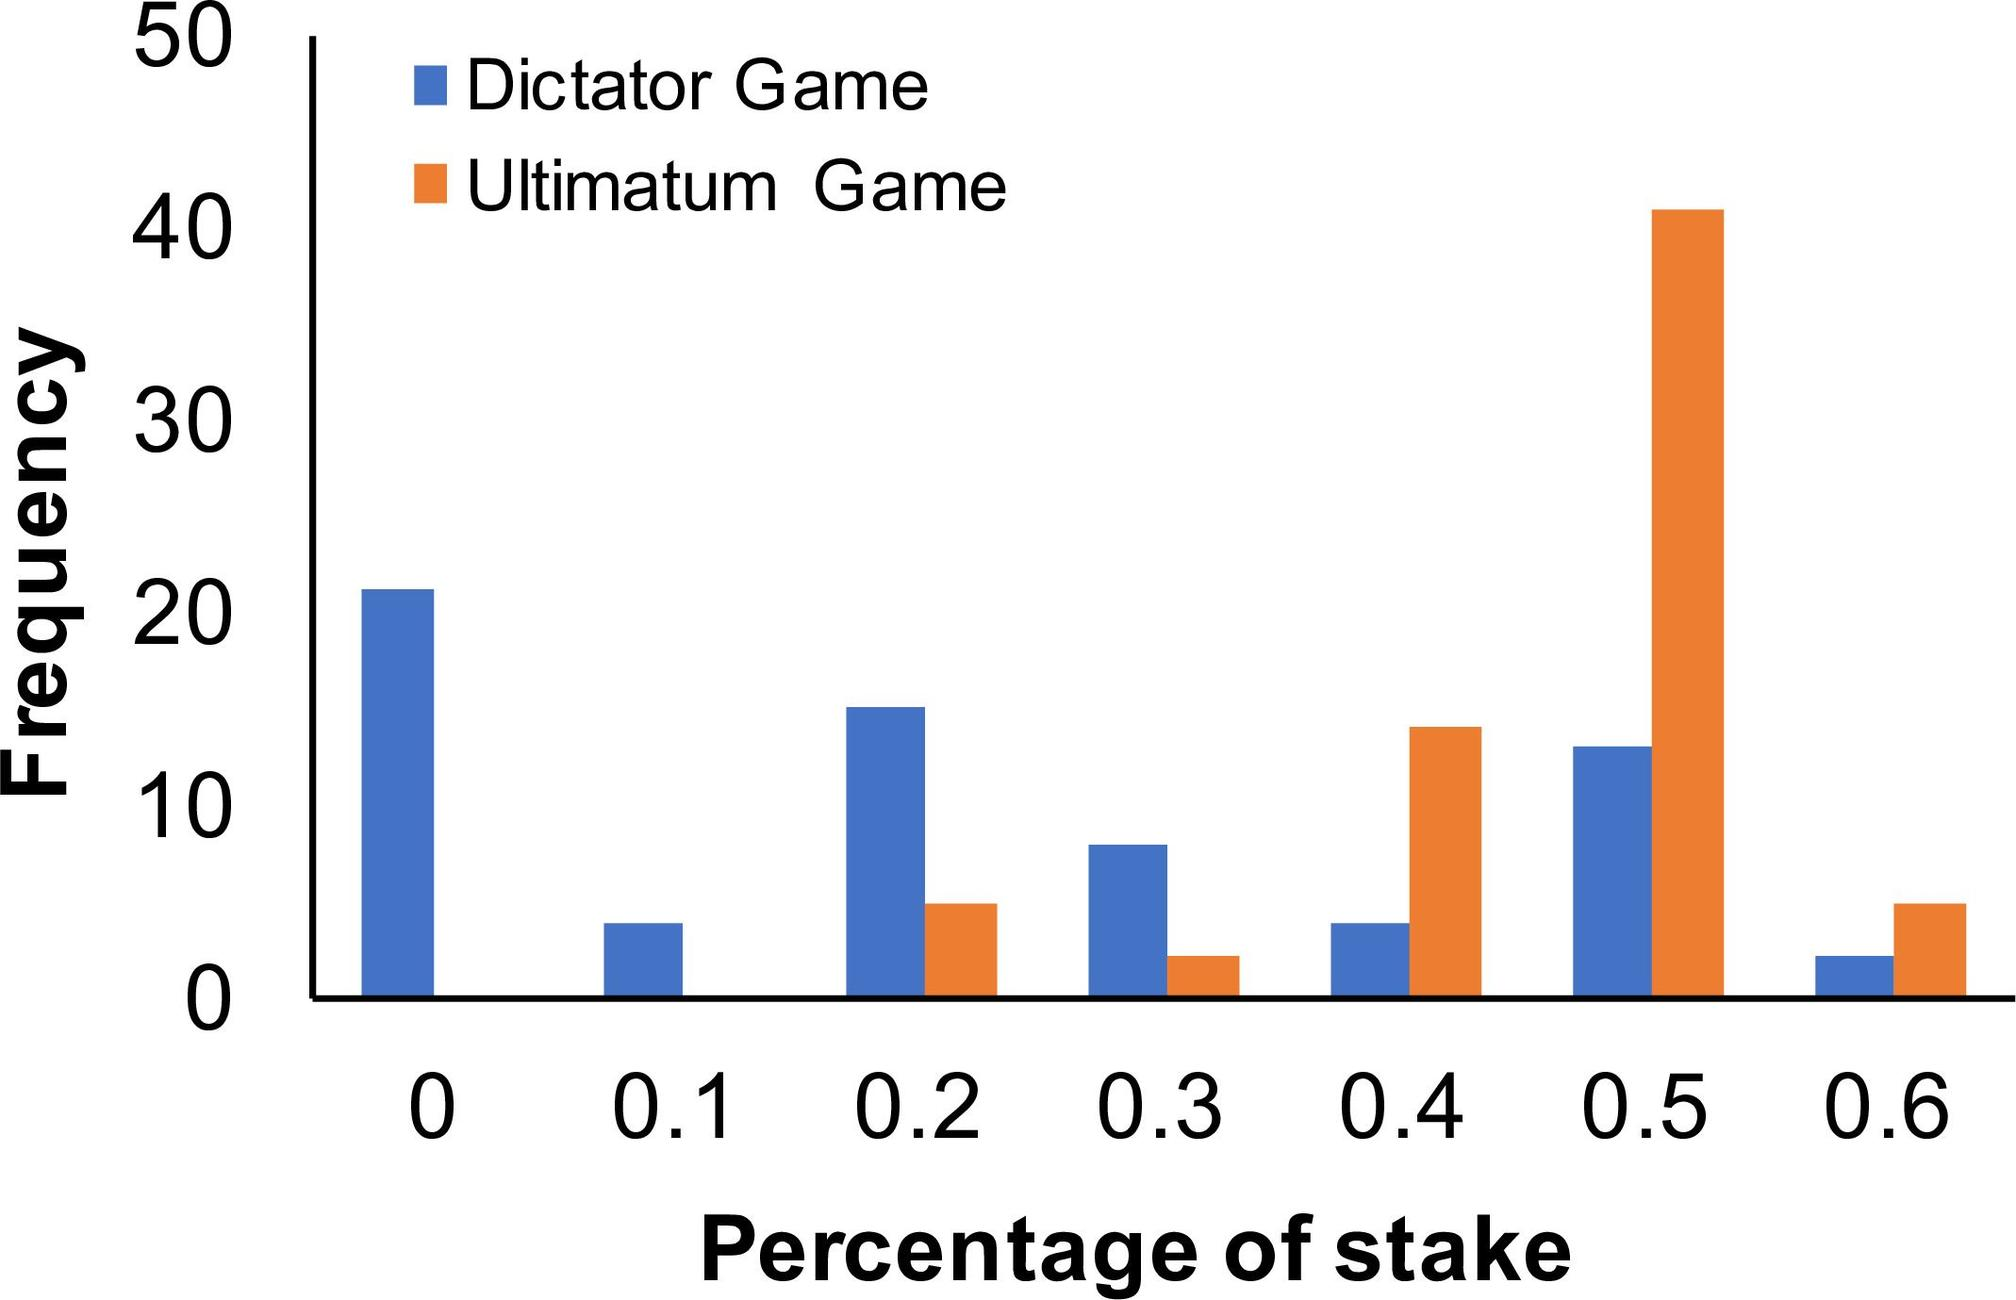Explain the importance of understanding these frequency patterns in experimental economics. Analyzing these frequency patterns is crucial in experimental economics as it helps illuminate how individuals make decisions under different conditions and rules. Insights from such data contribute to theories of economic behavior, including understanding fairness, negotiation strategies, and how economic incentives influence actions within various game theoretical frameworks. 